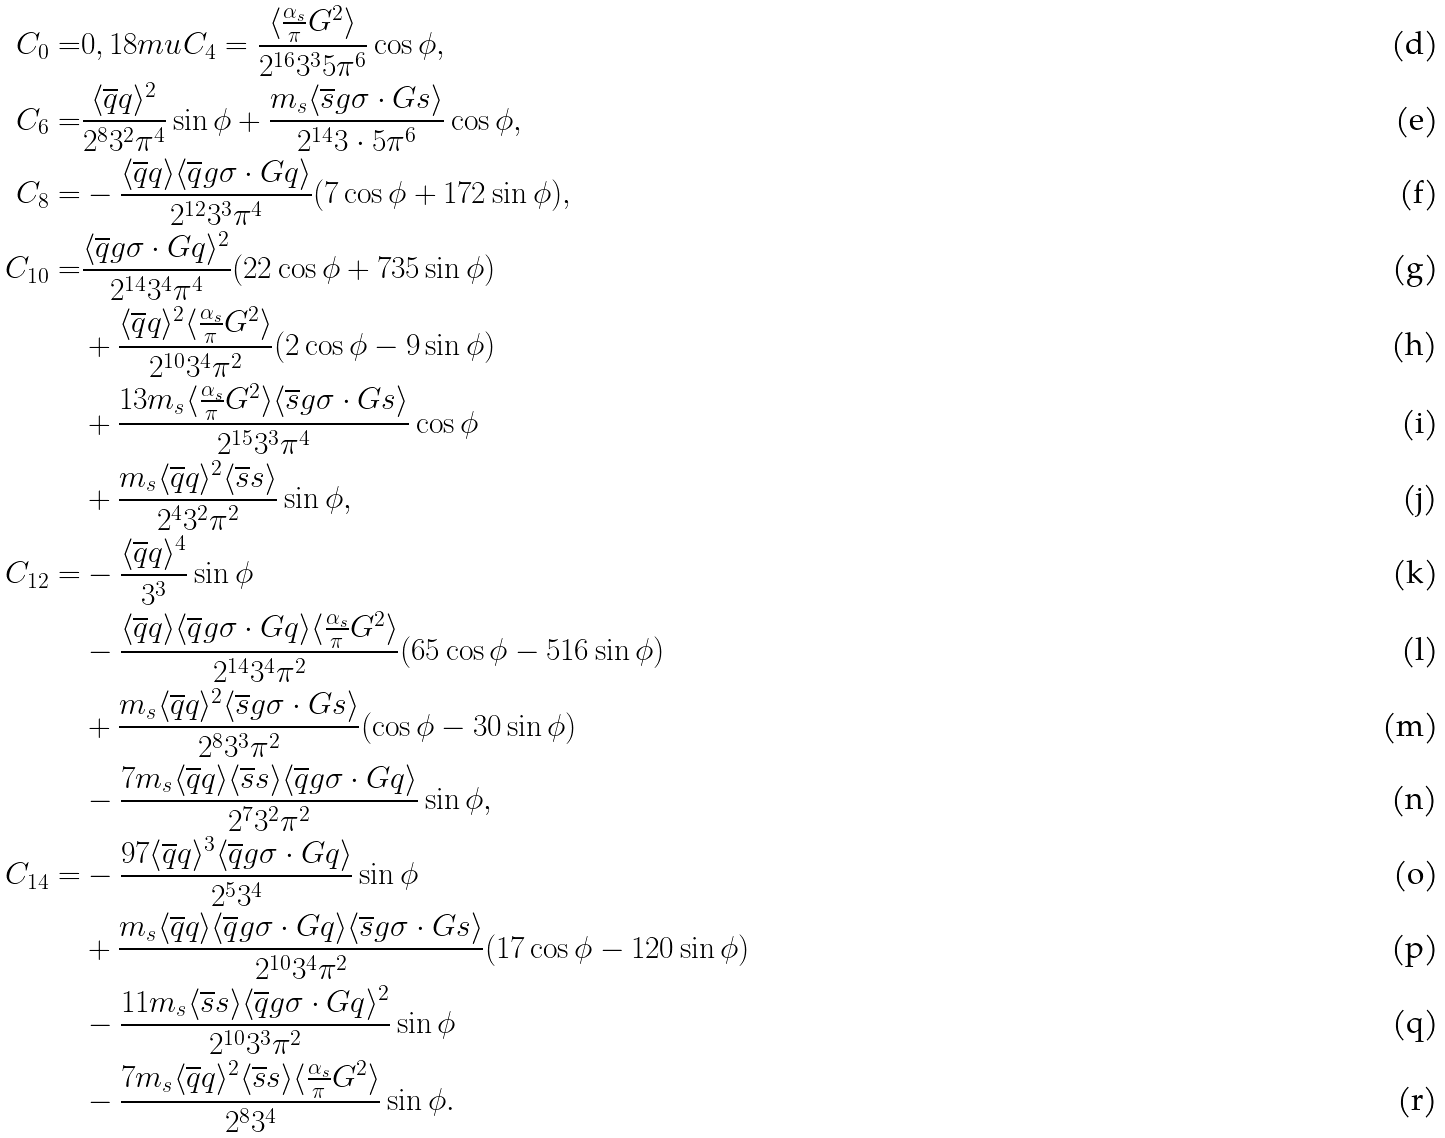Convert formula to latex. <formula><loc_0><loc_0><loc_500><loc_500>C _ { 0 } = & 0 , { 1 8 m u } C _ { 4 } = \frac { \langle \frac { \alpha _ { s } } { \pi } G ^ { 2 } \rangle } { 2 ^ { 1 6 } 3 ^ { 3 } 5 \pi ^ { 6 } } \cos \phi , \\ C _ { 6 } = & \frac { \langle \overline { q } q \rangle ^ { 2 } } { 2 ^ { 8 } 3 ^ { 2 } \pi ^ { 4 } } \sin \phi + \frac { m _ { s } \langle \overline { s } g \sigma \cdot G s \rangle } { 2 ^ { 1 4 } 3 \cdot 5 \pi ^ { 6 } } \cos \phi , \\ C _ { 8 } = & - \frac { \langle \overline { q } q \rangle \langle \overline { q } g \sigma \cdot G q \rangle } { 2 ^ { 1 2 } 3 ^ { 3 } \pi ^ { 4 } } ( 7 \cos \phi + 1 7 2 \sin \phi ) , \\ C _ { 1 0 } = & \frac { \langle \overline { q } g \sigma \cdot G q \rangle ^ { 2 } } { 2 ^ { 1 4 } 3 ^ { 4 } \pi ^ { 4 } } ( 2 2 \cos \phi + 7 3 5 \sin \phi ) \\ & + \frac { \langle \overline { q } q \rangle ^ { 2 } \langle \frac { \alpha _ { s } } { \pi } G ^ { 2 } \rangle } { 2 ^ { 1 0 } 3 ^ { 4 } \pi ^ { 2 } } ( 2 \cos \phi - 9 \sin \phi ) \\ & + \frac { 1 3 m _ { s } \langle \frac { \alpha _ { s } } { \pi } G ^ { 2 } \rangle \langle \overline { s } g \sigma \cdot G s \rangle } { 2 ^ { 1 5 } 3 ^ { 3 } \pi ^ { 4 } } \cos \phi \\ & + \frac { m _ { s } \langle \overline { q } q \rangle ^ { 2 } \langle \overline { s } s \rangle } { 2 ^ { 4 } 3 ^ { 2 } \pi ^ { 2 } } \sin \phi , \\ C _ { 1 2 } = & - \frac { \langle \overline { q } q \rangle ^ { 4 } } { 3 ^ { 3 } } \sin \phi \\ & - \frac { \langle \overline { q } q \rangle \langle \overline { q } g \sigma \cdot G q \rangle \langle \frac { \alpha _ { s } } { \pi } G ^ { 2 } \rangle } { 2 ^ { 1 4 } 3 ^ { 4 } \pi ^ { 2 } } ( 6 5 \cos \phi - 5 1 6 \sin \phi ) \\ & + \frac { m _ { s } \langle \overline { q } q \rangle ^ { 2 } \langle \overline { s } g \sigma \cdot G s \rangle } { 2 ^ { 8 } 3 ^ { 3 } \pi ^ { 2 } } ( \cos \phi - 3 0 \sin \phi ) \\ & - \frac { 7 m _ { s } \langle \overline { q } q \rangle \langle \overline { s } s \rangle \langle \overline { q } g \sigma \cdot G q \rangle } { 2 ^ { 7 } 3 ^ { 2 } \pi ^ { 2 } } \sin \phi , \\ C _ { 1 4 } = & - \frac { 9 7 \langle \overline { q } q \rangle ^ { 3 } \langle \overline { q } g \sigma \cdot G q \rangle } { 2 ^ { 5 } 3 ^ { 4 } } \sin \phi \\ & + \frac { m _ { s } \langle \overline { q } q \rangle \langle \overline { q } g \sigma \cdot G q \rangle \langle \overline { s } g \sigma \cdot G s \rangle } { 2 ^ { 1 0 } 3 ^ { 4 } \pi ^ { 2 } } ( 1 7 \cos \phi - 1 2 0 \sin \phi ) \\ & - \frac { 1 1 m _ { s } \langle \overline { s } s \rangle \langle \overline { q } g \sigma \cdot G q \rangle ^ { 2 } } { 2 ^ { 1 0 } 3 ^ { 3 } \pi ^ { 2 } } \sin \phi \\ & - \frac { 7 m _ { s } \langle \overline { q } q \rangle ^ { 2 } \langle \overline { s } s \rangle \langle \frac { \alpha _ { s } } { \pi } G ^ { 2 } \rangle } { 2 ^ { 8 } 3 ^ { 4 } } \sin \phi .</formula> 